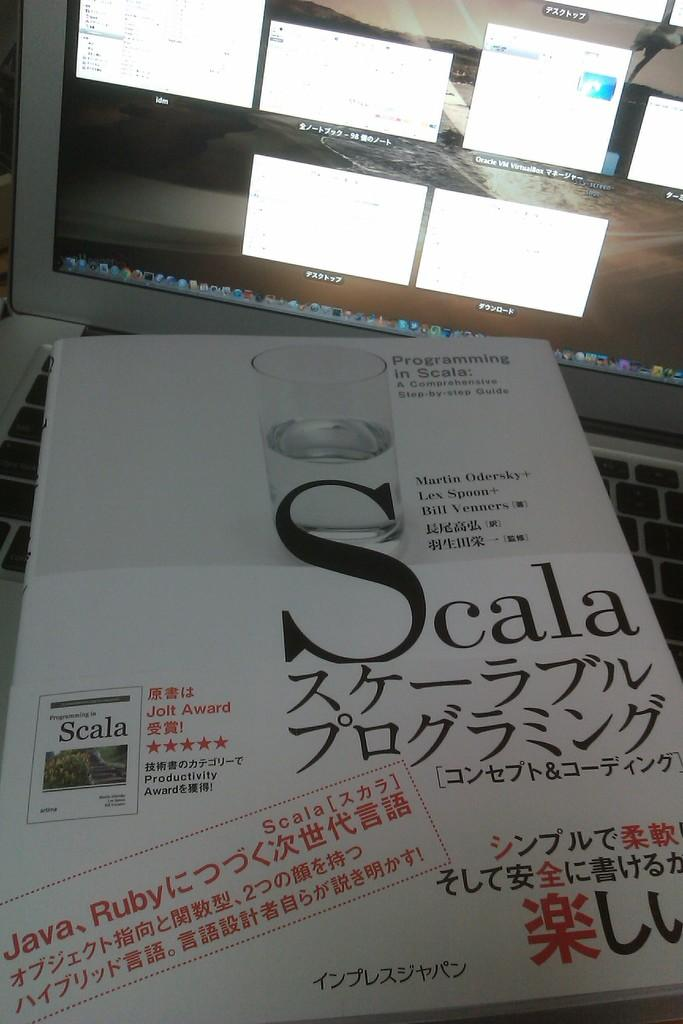<image>
Relay a brief, clear account of the picture shown. Scala is the brand printed on the front of this box. 